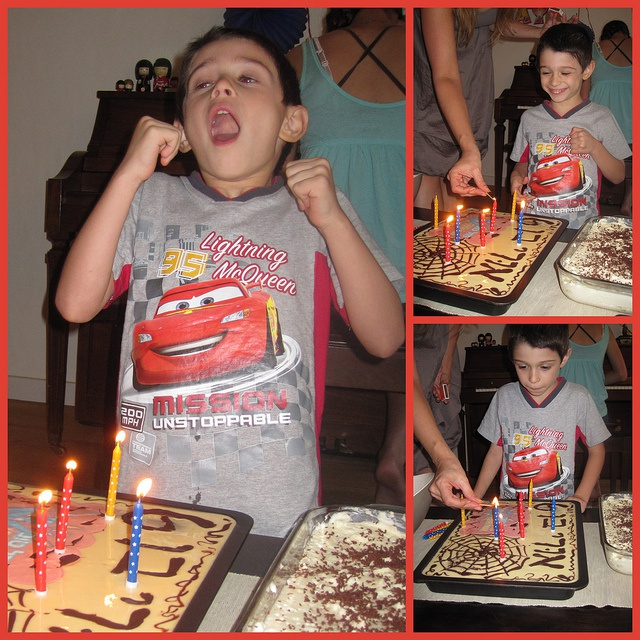Describe the objects in this image and their specific colors. I can see people in red, darkgray, brown, lightpink, and lightgray tones, cake in red, tan, and maroon tones, people in red, teal, maroon, and black tones, people in red, maroon, black, and brown tones, and people in red, darkgray, brown, black, and gray tones in this image. 